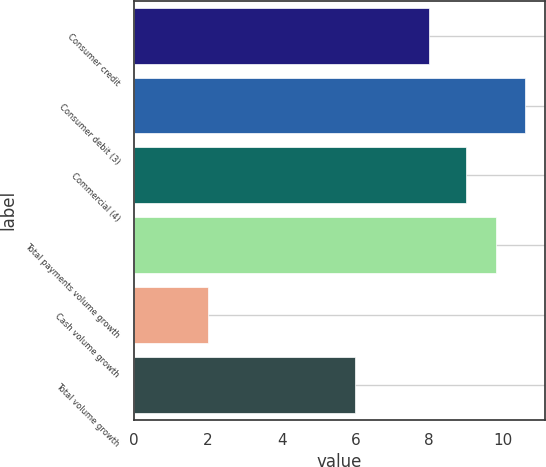Convert chart. <chart><loc_0><loc_0><loc_500><loc_500><bar_chart><fcel>Consumer credit<fcel>Consumer debit (3)<fcel>Commercial (4)<fcel>Total payments volume growth<fcel>Cash volume growth<fcel>Total volume growth<nl><fcel>8<fcel>10.6<fcel>9<fcel>9.8<fcel>2<fcel>6<nl></chart> 